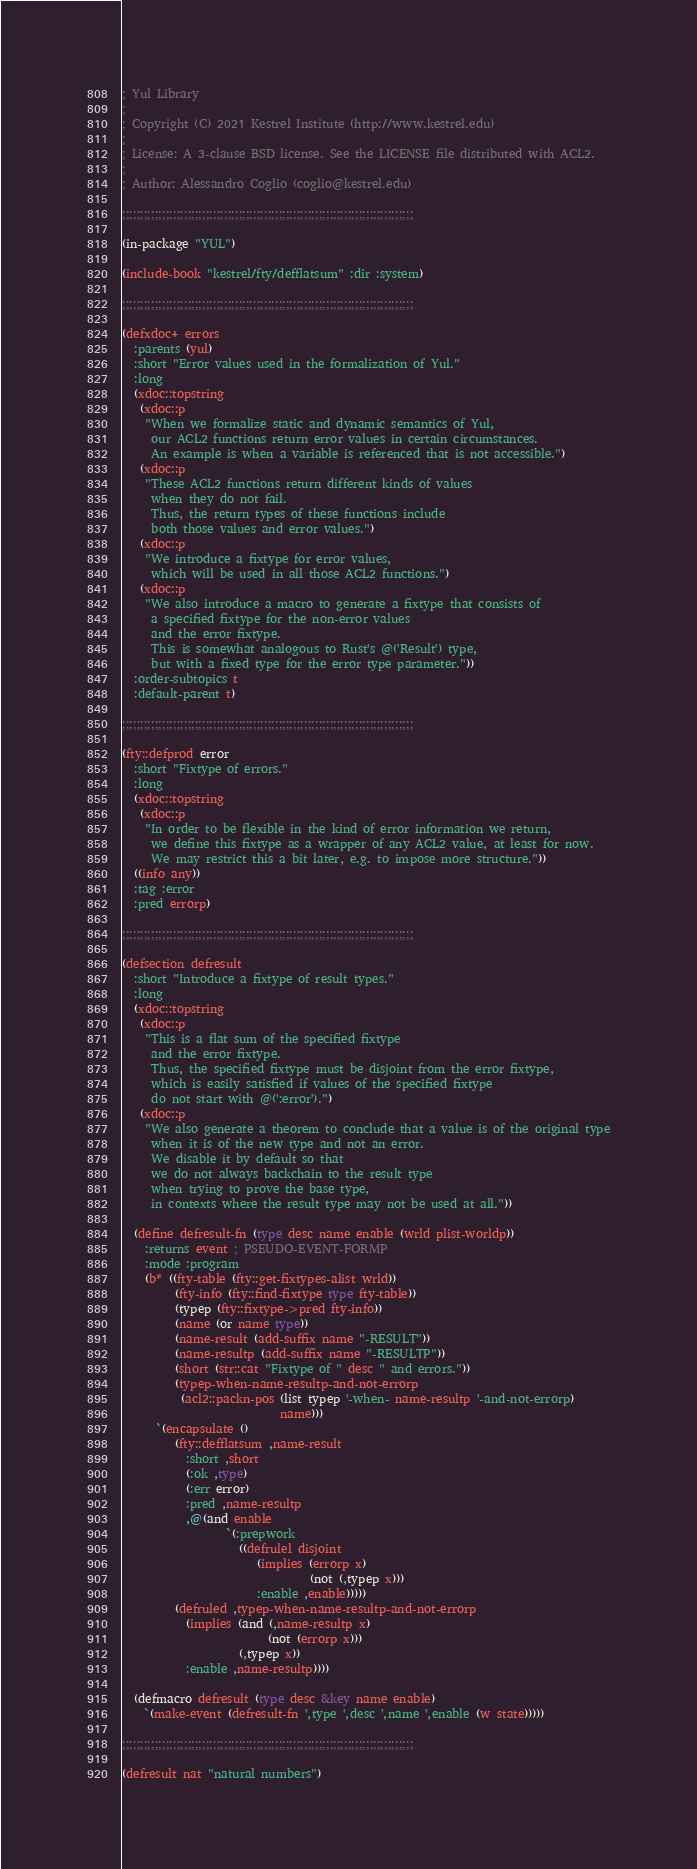<code> <loc_0><loc_0><loc_500><loc_500><_Lisp_>; Yul Library
;
; Copyright (C) 2021 Kestrel Institute (http://www.kestrel.edu)
;
; License: A 3-clause BSD license. See the LICENSE file distributed with ACL2.
;
; Author: Alessandro Coglio (coglio@kestrel.edu)

;;;;;;;;;;;;;;;;;;;;;;;;;;;;;;;;;;;;;;;;;;;;;;;;;;;;;;;;;;;;;;;;;;;;;;;;;;;;;;;;

(in-package "YUL")

(include-book "kestrel/fty/defflatsum" :dir :system)

;;;;;;;;;;;;;;;;;;;;;;;;;;;;;;;;;;;;;;;;;;;;;;;;;;;;;;;;;;;;;;;;;;;;;;;;;;;;;;;;

(defxdoc+ errors
  :parents (yul)
  :short "Error values used in the formalization of Yul."
  :long
  (xdoc::topstring
   (xdoc::p
    "When we formalize static and dynamic semantics of Yul,
     our ACL2 functions return error values in certain circumstances.
     An example is when a variable is referenced that is not accessible.")
   (xdoc::p
    "These ACL2 functions return different kinds of values
     when they do not fail.
     Thus, the return types of these functions include
     both those values and error values.")
   (xdoc::p
    "We introduce a fixtype for error values,
     which will be used in all those ACL2 functions.")
   (xdoc::p
    "We also introduce a macro to generate a fixtype that consists of
     a specified fixtype for the non-error values
     and the error fixtype.
     This is somewhat analogous to Rust's @('Result') type,
     but with a fixed type for the error type parameter."))
  :order-subtopics t
  :default-parent t)

;;;;;;;;;;;;;;;;;;;;;;;;;;;;;;;;;;;;;;;;;;;;;;;;;;;;;;;;;;;;;;;;;;;;;;;;;;;;;;;;

(fty::defprod error
  :short "Fixtype of errors."
  :long
  (xdoc::topstring
   (xdoc::p
    "In order to be flexible in the kind of error information we return,
     we define this fixtype as a wrapper of any ACL2 value, at least for now.
     We may restrict this a bit later, e.g. to impose more structure."))
  ((info any))
  :tag :error
  :pred errorp)

;;;;;;;;;;;;;;;;;;;;;;;;;;;;;;;;;;;;;;;;;;;;;;;;;;;;;;;;;;;;;;;;;;;;;;;;;;;;;;;;

(defsection defresult
  :short "Introduce a fixtype of result types."
  :long
  (xdoc::topstring
   (xdoc::p
    "This is a flat sum of the specified fixtype
     and the error fixtype.
     Thus, the specified fixtype must be disjoint from the error fixtype,
     which is easily satisfied if values of the specified fixtype
     do not start with @(':error').")
   (xdoc::p
    "We also generate a theorem to conclude that a value is of the original type
     when it is of the new type and not an error.
     We disable it by default so that
     we do not always backchain to the result type
     when trying to prove the base type,
     in contexts where the result type may not be used at all."))

  (define defresult-fn (type desc name enable (wrld plist-worldp))
    :returns event ; PSEUDO-EVENT-FORMP
    :mode :program
    (b* ((fty-table (fty::get-fixtypes-alist wrld))
         (fty-info (fty::find-fixtype type fty-table))
         (typep (fty::fixtype->pred fty-info))
         (name (or name type))
         (name-result (add-suffix name "-RESULT"))
         (name-resultp (add-suffix name "-RESULTP"))
         (short (str::cat "Fixtype of " desc " and errors."))
         (typep-when-name-resultp-and-not-errorp
          (acl2::packn-pos (list typep '-when- name-resultp '-and-not-errorp)
                           name)))
      `(encapsulate ()
         (fty::defflatsum ,name-result
           :short ,short
           (:ok ,type)
           (:err error)
           :pred ,name-resultp
           ,@(and enable
                  `(:prepwork
                    ((defrulel disjoint
                       (implies (errorp x)
                                (not (,typep x)))
                       :enable ,enable)))))
         (defruled ,typep-when-name-resultp-and-not-errorp
           (implies (and (,name-resultp x)
                         (not (errorp x)))
                    (,typep x))
           :enable ,name-resultp))))

  (defmacro defresult (type desc &key name enable)
    `(make-event (defresult-fn ',type ',desc ',name ',enable (w state)))))

;;;;;;;;;;;;;;;;;;;;;;;;;;;;;;;;;;;;;;;;;;;;;;;;;;;;;;;;;;;;;;;;;;;;;;;;;;;;;;;;

(defresult nat "natural numbers")
</code> 